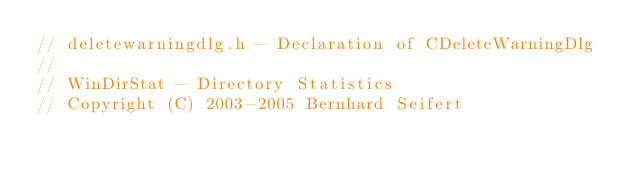<code> <loc_0><loc_0><loc_500><loc_500><_C_>// deletewarningdlg.h - Declaration of CDeleteWarningDlg
//
// WinDirStat - Directory Statistics
// Copyright (C) 2003-2005 Bernhard Seifert</code> 